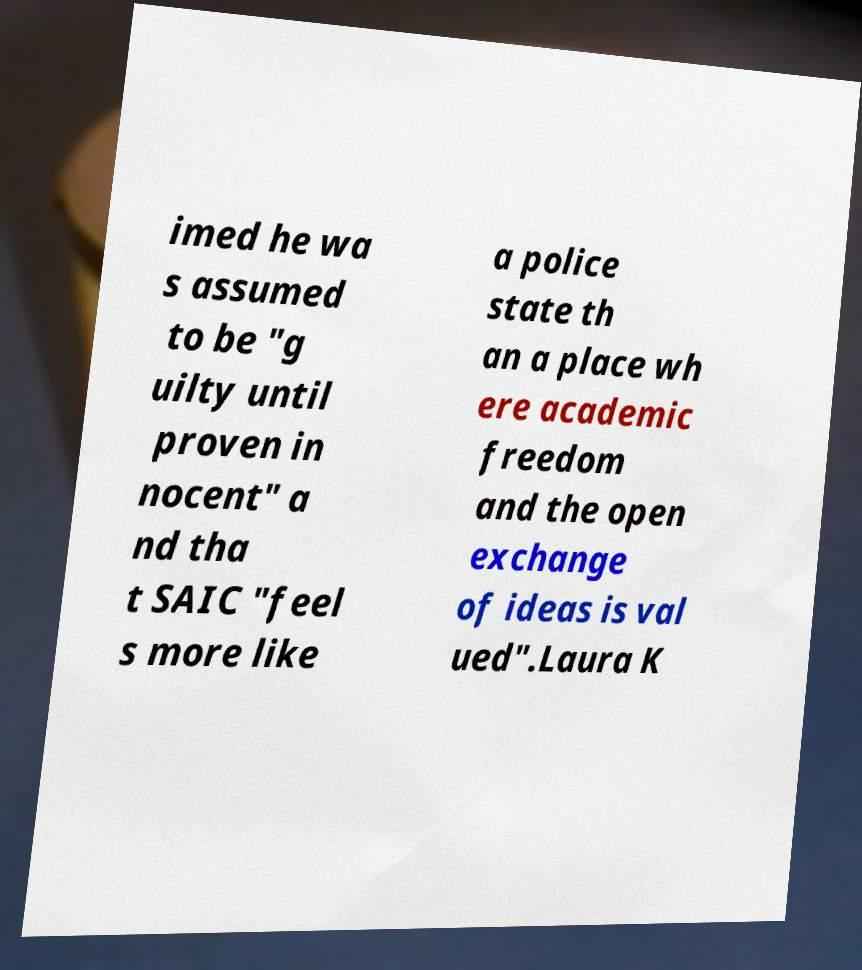Can you read and provide the text displayed in the image?This photo seems to have some interesting text. Can you extract and type it out for me? imed he wa s assumed to be "g uilty until proven in nocent" a nd tha t SAIC "feel s more like a police state th an a place wh ere academic freedom and the open exchange of ideas is val ued".Laura K 